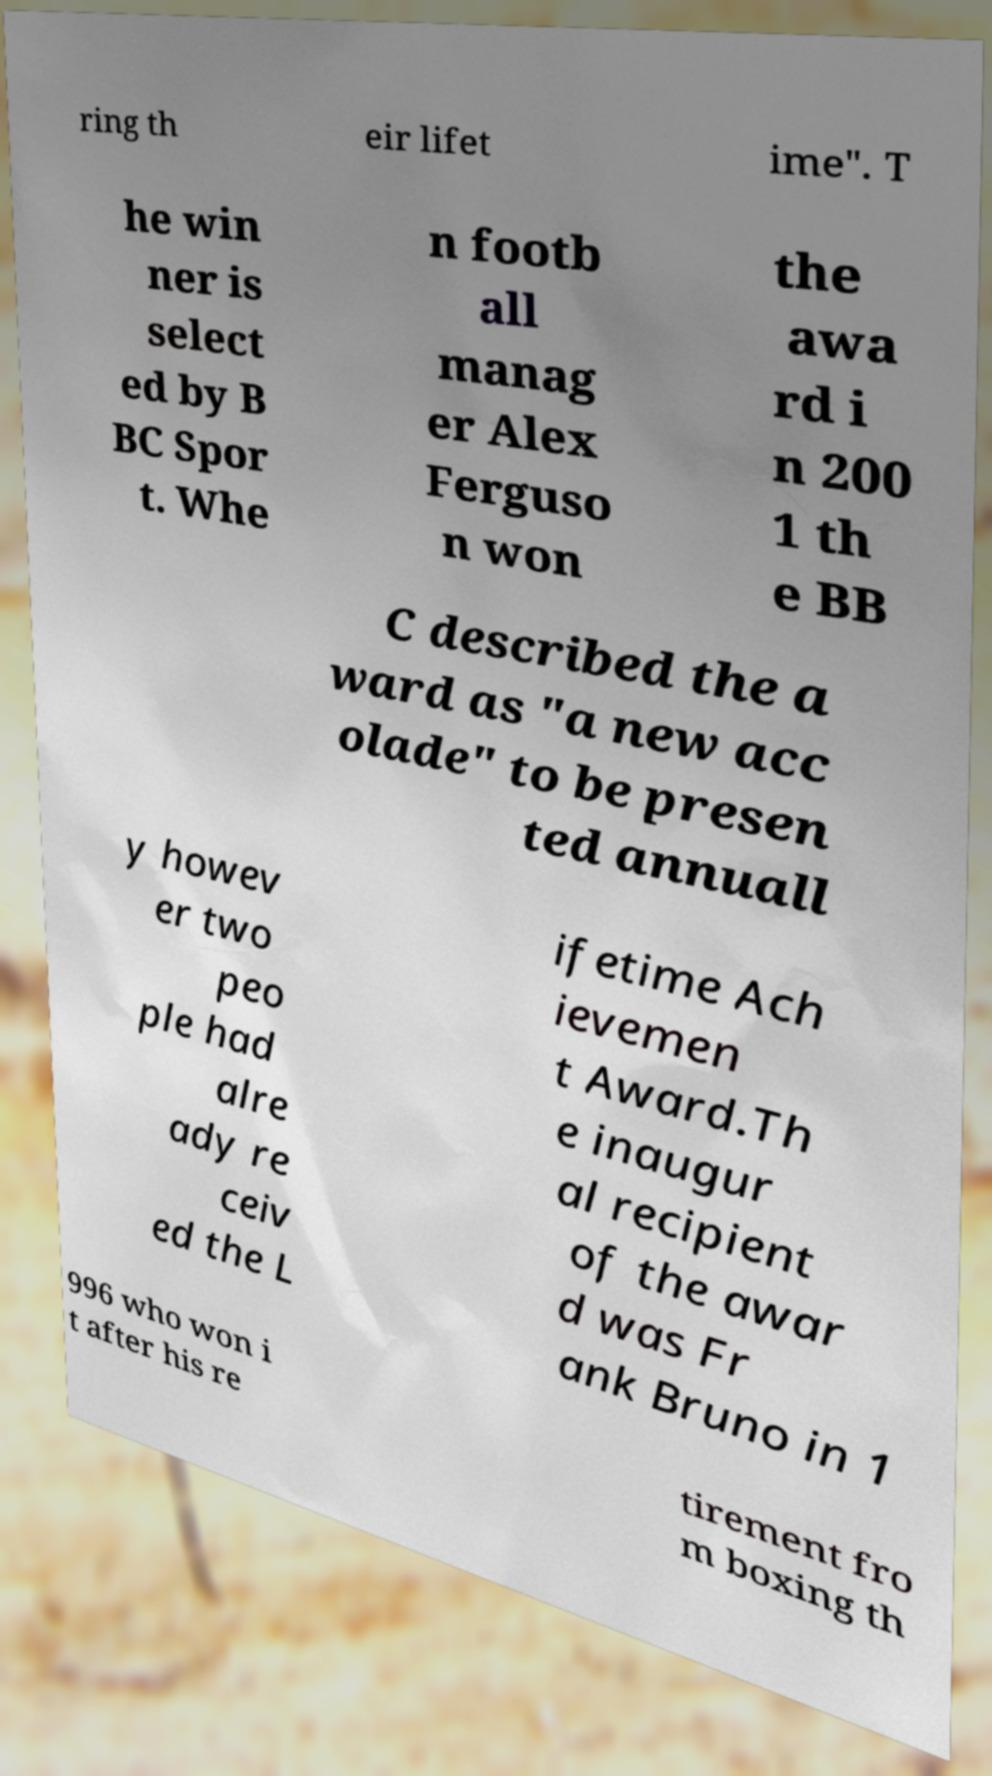For documentation purposes, I need the text within this image transcribed. Could you provide that? ring th eir lifet ime". T he win ner is select ed by B BC Spor t. Whe n footb all manag er Alex Ferguso n won the awa rd i n 200 1 th e BB C described the a ward as "a new acc olade" to be presen ted annuall y howev er two peo ple had alre ady re ceiv ed the L ifetime Ach ievemen t Award.Th e inaugur al recipient of the awar d was Fr ank Bruno in 1 996 who won i t after his re tirement fro m boxing th 